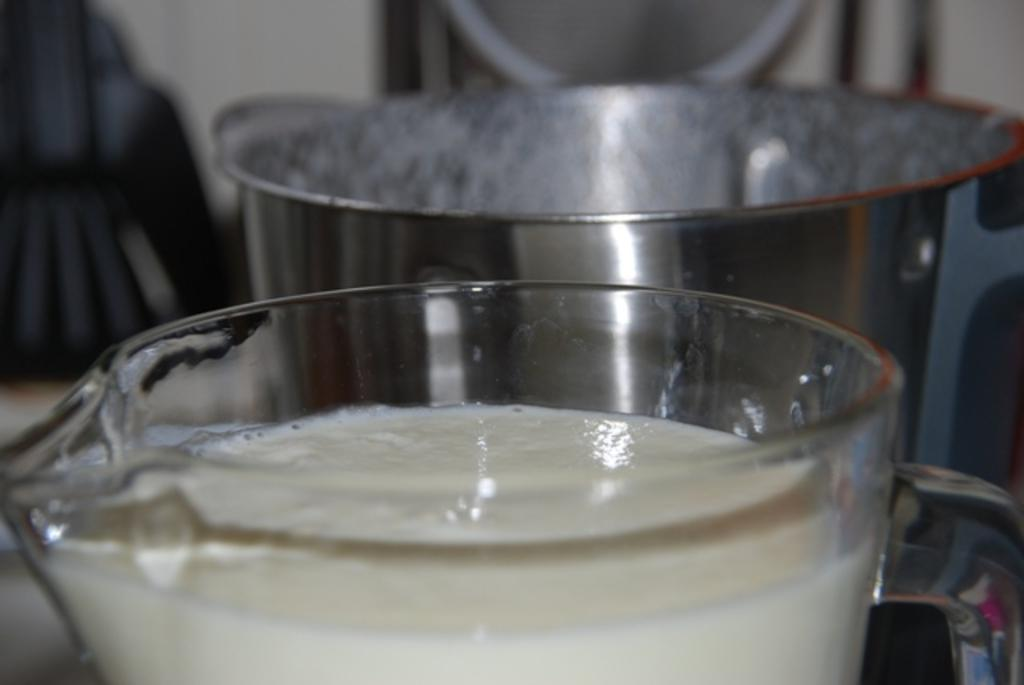What is the main object in the foreground of the image? There is a glass jar in the foreground of the image. What is inside the glass jar? There is a liquid in the glass jar. What other object is near the glass jar? There is a steel vessel beside the glass jar. Can you describe the background of the image? The background of the image is blurry. Is there a hook in the middle of the image? There is no hook present in the image. What emotion is being expressed by the objects in the image? The objects in the image do not express emotions, as they are inanimate. 